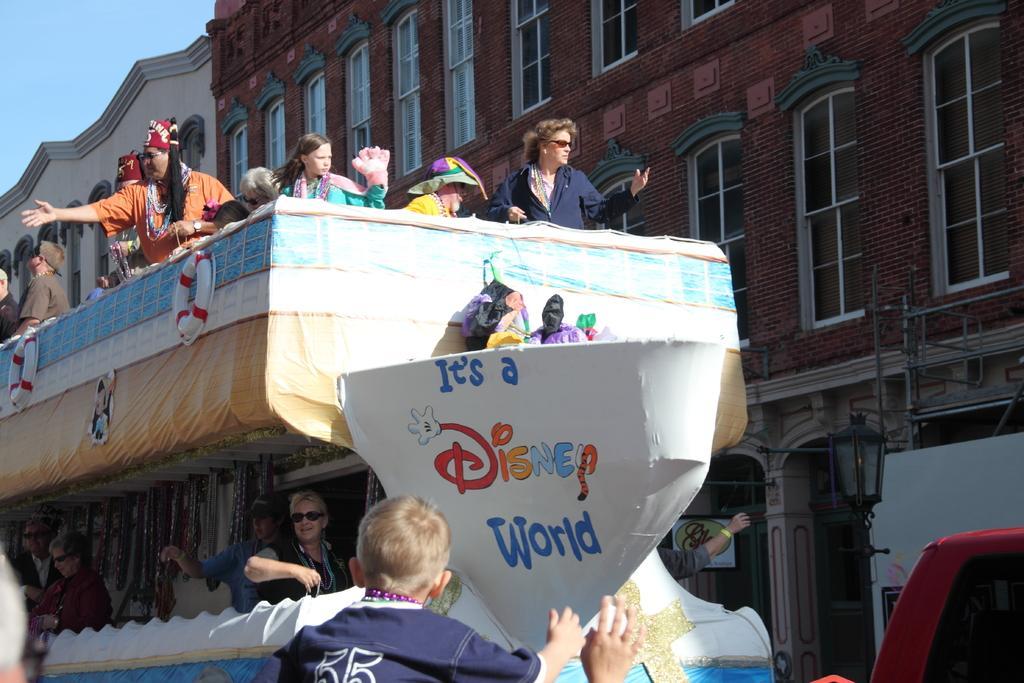Can you describe this image briefly? In this image I can see number of people in the front. I can also see a white colour thing in the front and on it I can see something is written. In the background I can see few buildings, number of windows, the sky, a light and on the bottom right corner of this image I can see a red colour thing. 